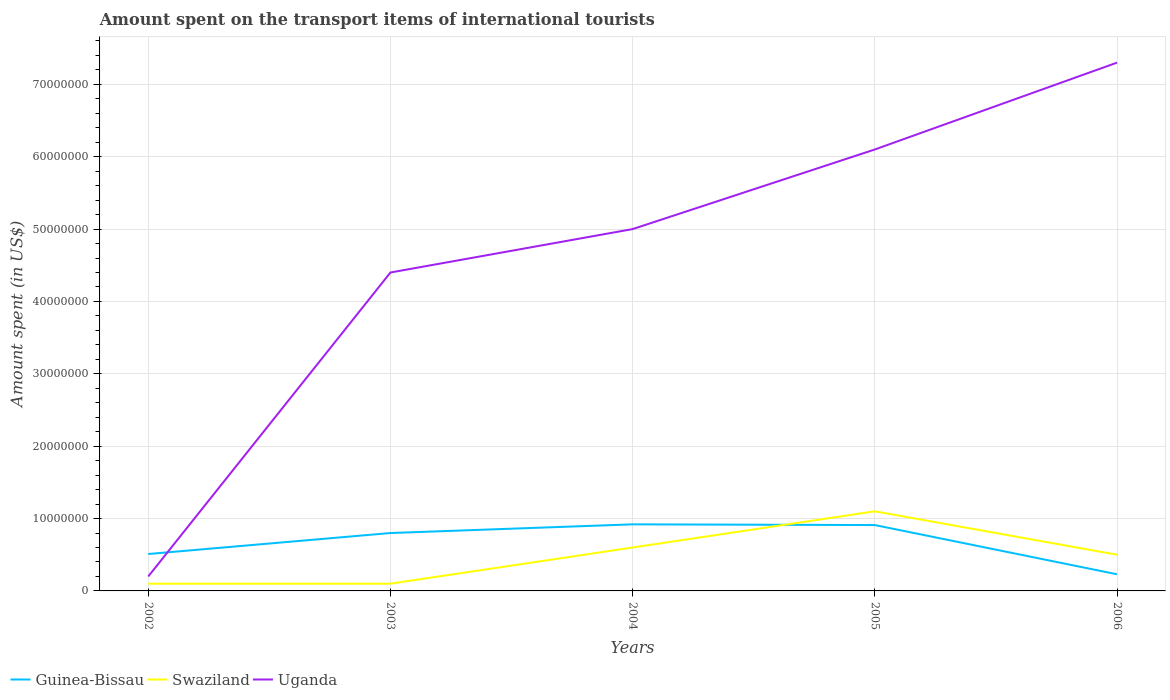How many different coloured lines are there?
Keep it short and to the point. 3. Does the line corresponding to Swaziland intersect with the line corresponding to Uganda?
Make the answer very short. No. Is the number of lines equal to the number of legend labels?
Make the answer very short. Yes. Across all years, what is the maximum amount spent on the transport items of international tourists in Swaziland?
Provide a succinct answer. 1.00e+06. In which year was the amount spent on the transport items of international tourists in Guinea-Bissau maximum?
Your response must be concise. 2006. What is the total amount spent on the transport items of international tourists in Uganda in the graph?
Give a very brief answer. -2.30e+07. What is the difference between the highest and the second highest amount spent on the transport items of international tourists in Uganda?
Provide a short and direct response. 7.10e+07. What is the difference between the highest and the lowest amount spent on the transport items of international tourists in Uganda?
Offer a very short reply. 3. Is the amount spent on the transport items of international tourists in Guinea-Bissau strictly greater than the amount spent on the transport items of international tourists in Uganda over the years?
Offer a terse response. No. How many lines are there?
Your response must be concise. 3. What is the difference between two consecutive major ticks on the Y-axis?
Your answer should be very brief. 1.00e+07. Are the values on the major ticks of Y-axis written in scientific E-notation?
Your answer should be very brief. No. Does the graph contain grids?
Offer a very short reply. Yes. How many legend labels are there?
Offer a very short reply. 3. How are the legend labels stacked?
Your answer should be very brief. Horizontal. What is the title of the graph?
Provide a succinct answer. Amount spent on the transport items of international tourists. Does "Fragile and conflict affected situations" appear as one of the legend labels in the graph?
Keep it short and to the point. No. What is the label or title of the X-axis?
Provide a short and direct response. Years. What is the label or title of the Y-axis?
Give a very brief answer. Amount spent (in US$). What is the Amount spent (in US$) in Guinea-Bissau in 2002?
Your response must be concise. 5.10e+06. What is the Amount spent (in US$) in Swaziland in 2002?
Provide a short and direct response. 1.00e+06. What is the Amount spent (in US$) of Uganda in 2002?
Keep it short and to the point. 2.00e+06. What is the Amount spent (in US$) of Uganda in 2003?
Your answer should be compact. 4.40e+07. What is the Amount spent (in US$) in Guinea-Bissau in 2004?
Provide a succinct answer. 9.20e+06. What is the Amount spent (in US$) in Uganda in 2004?
Your response must be concise. 5.00e+07. What is the Amount spent (in US$) in Guinea-Bissau in 2005?
Ensure brevity in your answer.  9.10e+06. What is the Amount spent (in US$) in Swaziland in 2005?
Give a very brief answer. 1.10e+07. What is the Amount spent (in US$) of Uganda in 2005?
Give a very brief answer. 6.10e+07. What is the Amount spent (in US$) of Guinea-Bissau in 2006?
Your answer should be compact. 2.30e+06. What is the Amount spent (in US$) in Swaziland in 2006?
Keep it short and to the point. 5.00e+06. What is the Amount spent (in US$) in Uganda in 2006?
Provide a short and direct response. 7.30e+07. Across all years, what is the maximum Amount spent (in US$) in Guinea-Bissau?
Make the answer very short. 9.20e+06. Across all years, what is the maximum Amount spent (in US$) of Swaziland?
Offer a very short reply. 1.10e+07. Across all years, what is the maximum Amount spent (in US$) in Uganda?
Your answer should be compact. 7.30e+07. Across all years, what is the minimum Amount spent (in US$) of Guinea-Bissau?
Your response must be concise. 2.30e+06. What is the total Amount spent (in US$) of Guinea-Bissau in the graph?
Offer a terse response. 3.37e+07. What is the total Amount spent (in US$) in Swaziland in the graph?
Your response must be concise. 2.40e+07. What is the total Amount spent (in US$) of Uganda in the graph?
Offer a terse response. 2.30e+08. What is the difference between the Amount spent (in US$) in Guinea-Bissau in 2002 and that in 2003?
Offer a terse response. -2.90e+06. What is the difference between the Amount spent (in US$) of Uganda in 2002 and that in 2003?
Provide a succinct answer. -4.20e+07. What is the difference between the Amount spent (in US$) of Guinea-Bissau in 2002 and that in 2004?
Offer a terse response. -4.10e+06. What is the difference between the Amount spent (in US$) in Swaziland in 2002 and that in 2004?
Your response must be concise. -5.00e+06. What is the difference between the Amount spent (in US$) of Uganda in 2002 and that in 2004?
Your answer should be compact. -4.80e+07. What is the difference between the Amount spent (in US$) in Swaziland in 2002 and that in 2005?
Offer a terse response. -1.00e+07. What is the difference between the Amount spent (in US$) of Uganda in 2002 and that in 2005?
Your answer should be compact. -5.90e+07. What is the difference between the Amount spent (in US$) of Guinea-Bissau in 2002 and that in 2006?
Your answer should be very brief. 2.80e+06. What is the difference between the Amount spent (in US$) of Swaziland in 2002 and that in 2006?
Your response must be concise. -4.00e+06. What is the difference between the Amount spent (in US$) of Uganda in 2002 and that in 2006?
Provide a succinct answer. -7.10e+07. What is the difference between the Amount spent (in US$) in Guinea-Bissau in 2003 and that in 2004?
Ensure brevity in your answer.  -1.20e+06. What is the difference between the Amount spent (in US$) in Swaziland in 2003 and that in 2004?
Give a very brief answer. -5.00e+06. What is the difference between the Amount spent (in US$) of Uganda in 2003 and that in 2004?
Keep it short and to the point. -6.00e+06. What is the difference between the Amount spent (in US$) of Guinea-Bissau in 2003 and that in 2005?
Keep it short and to the point. -1.10e+06. What is the difference between the Amount spent (in US$) in Swaziland in 2003 and that in 2005?
Keep it short and to the point. -1.00e+07. What is the difference between the Amount spent (in US$) in Uganda in 2003 and that in 2005?
Keep it short and to the point. -1.70e+07. What is the difference between the Amount spent (in US$) of Guinea-Bissau in 2003 and that in 2006?
Your answer should be compact. 5.70e+06. What is the difference between the Amount spent (in US$) of Swaziland in 2003 and that in 2006?
Ensure brevity in your answer.  -4.00e+06. What is the difference between the Amount spent (in US$) of Uganda in 2003 and that in 2006?
Provide a succinct answer. -2.90e+07. What is the difference between the Amount spent (in US$) in Swaziland in 2004 and that in 2005?
Offer a very short reply. -5.00e+06. What is the difference between the Amount spent (in US$) of Uganda in 2004 and that in 2005?
Offer a very short reply. -1.10e+07. What is the difference between the Amount spent (in US$) of Guinea-Bissau in 2004 and that in 2006?
Provide a succinct answer. 6.90e+06. What is the difference between the Amount spent (in US$) in Swaziland in 2004 and that in 2006?
Offer a very short reply. 1.00e+06. What is the difference between the Amount spent (in US$) of Uganda in 2004 and that in 2006?
Your response must be concise. -2.30e+07. What is the difference between the Amount spent (in US$) of Guinea-Bissau in 2005 and that in 2006?
Provide a succinct answer. 6.80e+06. What is the difference between the Amount spent (in US$) in Uganda in 2005 and that in 2006?
Make the answer very short. -1.20e+07. What is the difference between the Amount spent (in US$) in Guinea-Bissau in 2002 and the Amount spent (in US$) in Swaziland in 2003?
Make the answer very short. 4.10e+06. What is the difference between the Amount spent (in US$) of Guinea-Bissau in 2002 and the Amount spent (in US$) of Uganda in 2003?
Your response must be concise. -3.89e+07. What is the difference between the Amount spent (in US$) of Swaziland in 2002 and the Amount spent (in US$) of Uganda in 2003?
Make the answer very short. -4.30e+07. What is the difference between the Amount spent (in US$) of Guinea-Bissau in 2002 and the Amount spent (in US$) of Swaziland in 2004?
Provide a succinct answer. -9.00e+05. What is the difference between the Amount spent (in US$) in Guinea-Bissau in 2002 and the Amount spent (in US$) in Uganda in 2004?
Your answer should be very brief. -4.49e+07. What is the difference between the Amount spent (in US$) of Swaziland in 2002 and the Amount spent (in US$) of Uganda in 2004?
Keep it short and to the point. -4.90e+07. What is the difference between the Amount spent (in US$) of Guinea-Bissau in 2002 and the Amount spent (in US$) of Swaziland in 2005?
Make the answer very short. -5.90e+06. What is the difference between the Amount spent (in US$) in Guinea-Bissau in 2002 and the Amount spent (in US$) in Uganda in 2005?
Make the answer very short. -5.59e+07. What is the difference between the Amount spent (in US$) of Swaziland in 2002 and the Amount spent (in US$) of Uganda in 2005?
Offer a very short reply. -6.00e+07. What is the difference between the Amount spent (in US$) of Guinea-Bissau in 2002 and the Amount spent (in US$) of Uganda in 2006?
Make the answer very short. -6.79e+07. What is the difference between the Amount spent (in US$) in Swaziland in 2002 and the Amount spent (in US$) in Uganda in 2006?
Your answer should be compact. -7.20e+07. What is the difference between the Amount spent (in US$) in Guinea-Bissau in 2003 and the Amount spent (in US$) in Swaziland in 2004?
Ensure brevity in your answer.  2.00e+06. What is the difference between the Amount spent (in US$) in Guinea-Bissau in 2003 and the Amount spent (in US$) in Uganda in 2004?
Provide a short and direct response. -4.20e+07. What is the difference between the Amount spent (in US$) in Swaziland in 2003 and the Amount spent (in US$) in Uganda in 2004?
Make the answer very short. -4.90e+07. What is the difference between the Amount spent (in US$) of Guinea-Bissau in 2003 and the Amount spent (in US$) of Uganda in 2005?
Keep it short and to the point. -5.30e+07. What is the difference between the Amount spent (in US$) of Swaziland in 2003 and the Amount spent (in US$) of Uganda in 2005?
Provide a succinct answer. -6.00e+07. What is the difference between the Amount spent (in US$) of Guinea-Bissau in 2003 and the Amount spent (in US$) of Uganda in 2006?
Make the answer very short. -6.50e+07. What is the difference between the Amount spent (in US$) in Swaziland in 2003 and the Amount spent (in US$) in Uganda in 2006?
Provide a succinct answer. -7.20e+07. What is the difference between the Amount spent (in US$) in Guinea-Bissau in 2004 and the Amount spent (in US$) in Swaziland in 2005?
Offer a terse response. -1.80e+06. What is the difference between the Amount spent (in US$) in Guinea-Bissau in 2004 and the Amount spent (in US$) in Uganda in 2005?
Ensure brevity in your answer.  -5.18e+07. What is the difference between the Amount spent (in US$) in Swaziland in 2004 and the Amount spent (in US$) in Uganda in 2005?
Your response must be concise. -5.50e+07. What is the difference between the Amount spent (in US$) of Guinea-Bissau in 2004 and the Amount spent (in US$) of Swaziland in 2006?
Your answer should be very brief. 4.20e+06. What is the difference between the Amount spent (in US$) in Guinea-Bissau in 2004 and the Amount spent (in US$) in Uganda in 2006?
Your answer should be compact. -6.38e+07. What is the difference between the Amount spent (in US$) in Swaziland in 2004 and the Amount spent (in US$) in Uganda in 2006?
Provide a short and direct response. -6.70e+07. What is the difference between the Amount spent (in US$) of Guinea-Bissau in 2005 and the Amount spent (in US$) of Swaziland in 2006?
Provide a short and direct response. 4.10e+06. What is the difference between the Amount spent (in US$) in Guinea-Bissau in 2005 and the Amount spent (in US$) in Uganda in 2006?
Offer a very short reply. -6.39e+07. What is the difference between the Amount spent (in US$) in Swaziland in 2005 and the Amount spent (in US$) in Uganda in 2006?
Provide a short and direct response. -6.20e+07. What is the average Amount spent (in US$) of Guinea-Bissau per year?
Your answer should be compact. 6.74e+06. What is the average Amount spent (in US$) in Swaziland per year?
Offer a very short reply. 4.80e+06. What is the average Amount spent (in US$) of Uganda per year?
Keep it short and to the point. 4.60e+07. In the year 2002, what is the difference between the Amount spent (in US$) in Guinea-Bissau and Amount spent (in US$) in Swaziland?
Your response must be concise. 4.10e+06. In the year 2002, what is the difference between the Amount spent (in US$) of Guinea-Bissau and Amount spent (in US$) of Uganda?
Offer a terse response. 3.10e+06. In the year 2002, what is the difference between the Amount spent (in US$) of Swaziland and Amount spent (in US$) of Uganda?
Offer a very short reply. -1.00e+06. In the year 2003, what is the difference between the Amount spent (in US$) in Guinea-Bissau and Amount spent (in US$) in Swaziland?
Offer a terse response. 7.00e+06. In the year 2003, what is the difference between the Amount spent (in US$) in Guinea-Bissau and Amount spent (in US$) in Uganda?
Your response must be concise. -3.60e+07. In the year 2003, what is the difference between the Amount spent (in US$) of Swaziland and Amount spent (in US$) of Uganda?
Keep it short and to the point. -4.30e+07. In the year 2004, what is the difference between the Amount spent (in US$) of Guinea-Bissau and Amount spent (in US$) of Swaziland?
Keep it short and to the point. 3.20e+06. In the year 2004, what is the difference between the Amount spent (in US$) in Guinea-Bissau and Amount spent (in US$) in Uganda?
Your answer should be compact. -4.08e+07. In the year 2004, what is the difference between the Amount spent (in US$) of Swaziland and Amount spent (in US$) of Uganda?
Provide a succinct answer. -4.40e+07. In the year 2005, what is the difference between the Amount spent (in US$) in Guinea-Bissau and Amount spent (in US$) in Swaziland?
Offer a very short reply. -1.90e+06. In the year 2005, what is the difference between the Amount spent (in US$) in Guinea-Bissau and Amount spent (in US$) in Uganda?
Give a very brief answer. -5.19e+07. In the year 2005, what is the difference between the Amount spent (in US$) in Swaziland and Amount spent (in US$) in Uganda?
Offer a terse response. -5.00e+07. In the year 2006, what is the difference between the Amount spent (in US$) of Guinea-Bissau and Amount spent (in US$) of Swaziland?
Offer a very short reply. -2.70e+06. In the year 2006, what is the difference between the Amount spent (in US$) in Guinea-Bissau and Amount spent (in US$) in Uganda?
Offer a terse response. -7.07e+07. In the year 2006, what is the difference between the Amount spent (in US$) of Swaziland and Amount spent (in US$) of Uganda?
Your answer should be very brief. -6.80e+07. What is the ratio of the Amount spent (in US$) of Guinea-Bissau in 2002 to that in 2003?
Make the answer very short. 0.64. What is the ratio of the Amount spent (in US$) in Uganda in 2002 to that in 2003?
Provide a succinct answer. 0.05. What is the ratio of the Amount spent (in US$) of Guinea-Bissau in 2002 to that in 2004?
Your answer should be very brief. 0.55. What is the ratio of the Amount spent (in US$) in Swaziland in 2002 to that in 2004?
Provide a short and direct response. 0.17. What is the ratio of the Amount spent (in US$) in Uganda in 2002 to that in 2004?
Make the answer very short. 0.04. What is the ratio of the Amount spent (in US$) of Guinea-Bissau in 2002 to that in 2005?
Offer a terse response. 0.56. What is the ratio of the Amount spent (in US$) of Swaziland in 2002 to that in 2005?
Your answer should be compact. 0.09. What is the ratio of the Amount spent (in US$) in Uganda in 2002 to that in 2005?
Ensure brevity in your answer.  0.03. What is the ratio of the Amount spent (in US$) in Guinea-Bissau in 2002 to that in 2006?
Provide a short and direct response. 2.22. What is the ratio of the Amount spent (in US$) in Swaziland in 2002 to that in 2006?
Ensure brevity in your answer.  0.2. What is the ratio of the Amount spent (in US$) of Uganda in 2002 to that in 2006?
Your answer should be compact. 0.03. What is the ratio of the Amount spent (in US$) in Guinea-Bissau in 2003 to that in 2004?
Make the answer very short. 0.87. What is the ratio of the Amount spent (in US$) of Swaziland in 2003 to that in 2004?
Your answer should be very brief. 0.17. What is the ratio of the Amount spent (in US$) in Guinea-Bissau in 2003 to that in 2005?
Make the answer very short. 0.88. What is the ratio of the Amount spent (in US$) in Swaziland in 2003 to that in 2005?
Your answer should be very brief. 0.09. What is the ratio of the Amount spent (in US$) of Uganda in 2003 to that in 2005?
Offer a very short reply. 0.72. What is the ratio of the Amount spent (in US$) of Guinea-Bissau in 2003 to that in 2006?
Make the answer very short. 3.48. What is the ratio of the Amount spent (in US$) in Swaziland in 2003 to that in 2006?
Provide a short and direct response. 0.2. What is the ratio of the Amount spent (in US$) of Uganda in 2003 to that in 2006?
Make the answer very short. 0.6. What is the ratio of the Amount spent (in US$) of Guinea-Bissau in 2004 to that in 2005?
Keep it short and to the point. 1.01. What is the ratio of the Amount spent (in US$) in Swaziland in 2004 to that in 2005?
Your response must be concise. 0.55. What is the ratio of the Amount spent (in US$) in Uganda in 2004 to that in 2005?
Your answer should be compact. 0.82. What is the ratio of the Amount spent (in US$) in Swaziland in 2004 to that in 2006?
Provide a short and direct response. 1.2. What is the ratio of the Amount spent (in US$) in Uganda in 2004 to that in 2006?
Ensure brevity in your answer.  0.68. What is the ratio of the Amount spent (in US$) of Guinea-Bissau in 2005 to that in 2006?
Keep it short and to the point. 3.96. What is the ratio of the Amount spent (in US$) of Uganda in 2005 to that in 2006?
Provide a short and direct response. 0.84. What is the difference between the highest and the second highest Amount spent (in US$) in Guinea-Bissau?
Your response must be concise. 1.00e+05. What is the difference between the highest and the lowest Amount spent (in US$) in Guinea-Bissau?
Your answer should be very brief. 6.90e+06. What is the difference between the highest and the lowest Amount spent (in US$) of Uganda?
Your answer should be very brief. 7.10e+07. 